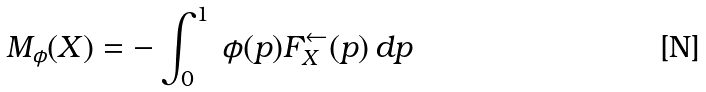<formula> <loc_0><loc_0><loc_500><loc_500>M _ { \phi } ( X ) = - \int _ { 0 } ^ { 1 } \, \phi ( p ) F _ { X } ^ { \leftarrow } ( p ) \, d p</formula> 